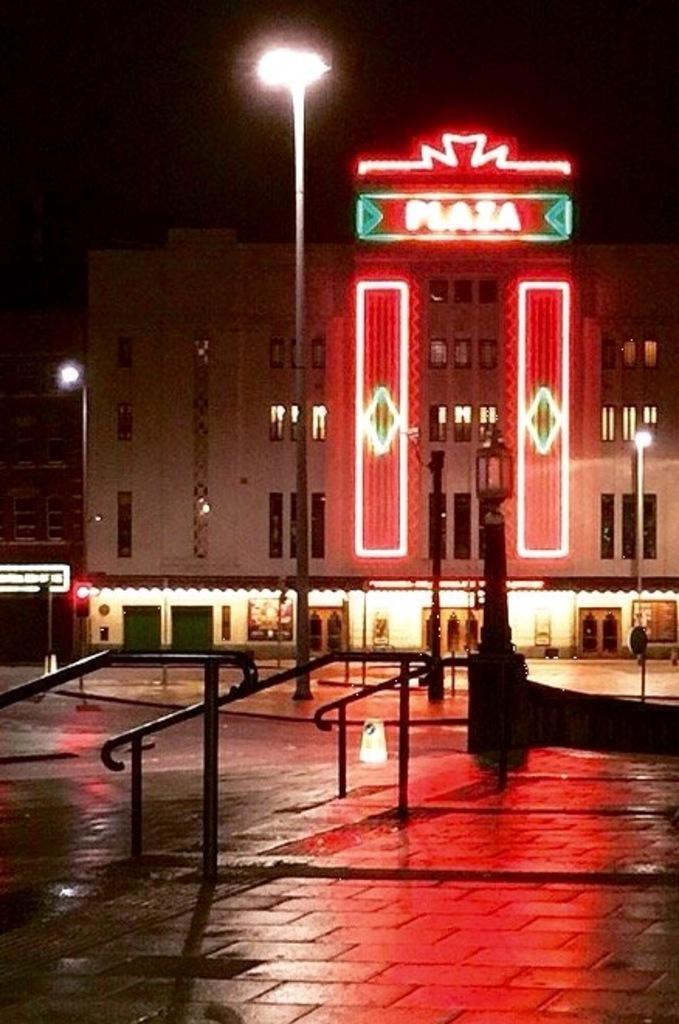Can you describe this image briefly? In this image we can see the buildings. And we can see the windows. And we can see some text written on the building. And we can see the street lights. And we can see the railing. 